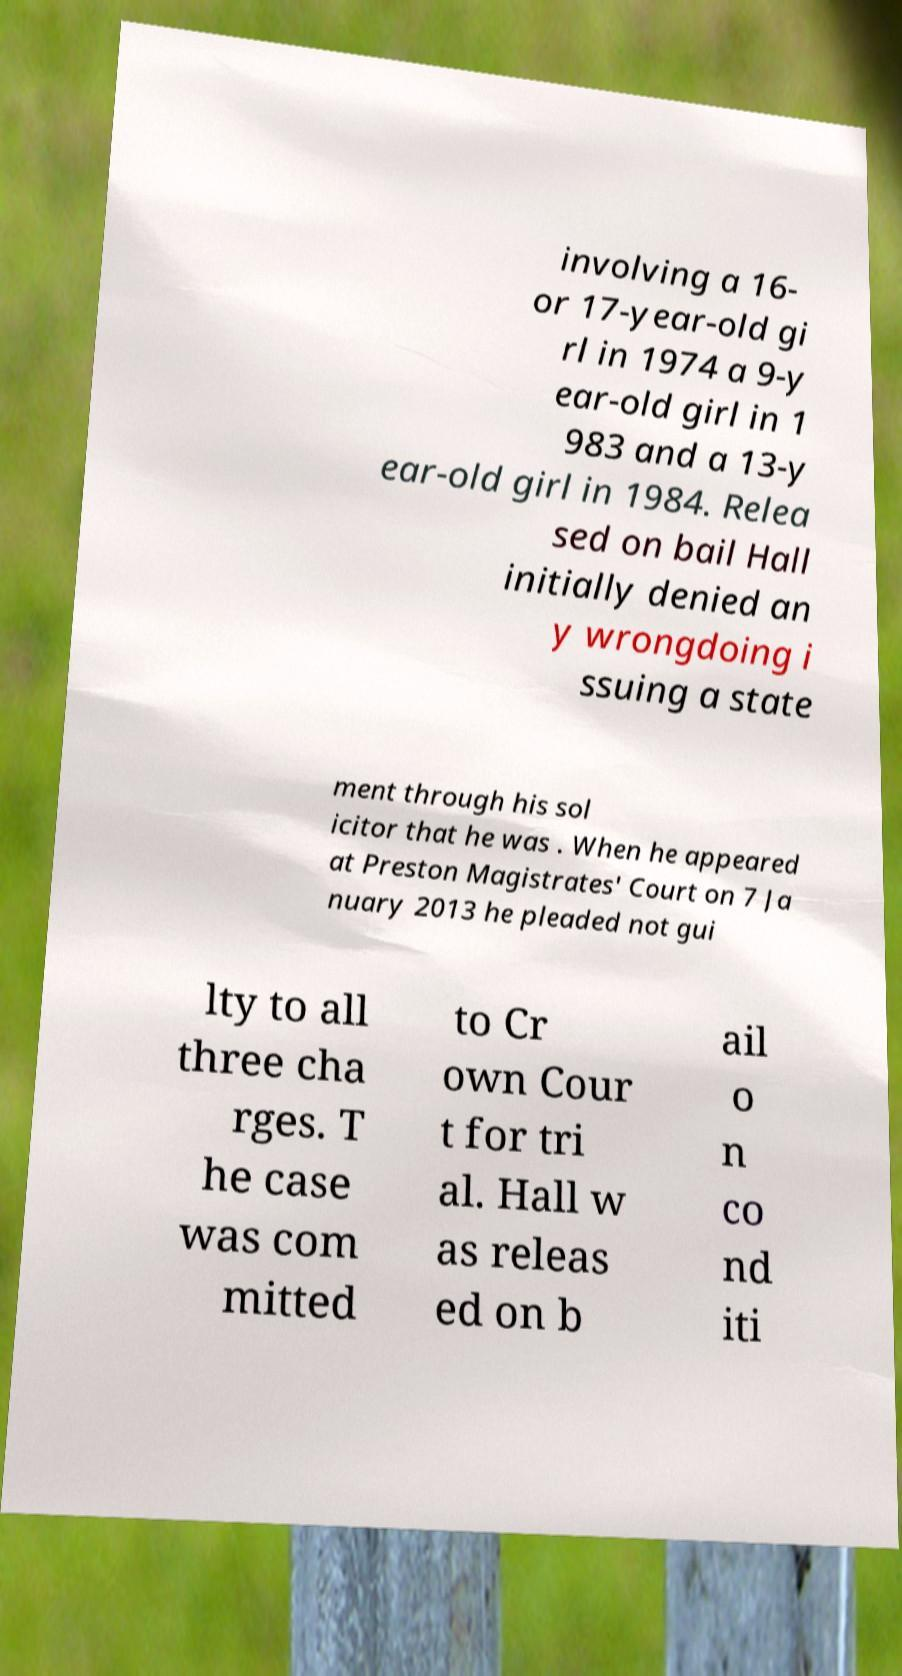Please read and relay the text visible in this image. What does it say? involving a 16- or 17-year-old gi rl in 1974 a 9-y ear-old girl in 1 983 and a 13-y ear-old girl in 1984. Relea sed on bail Hall initially denied an y wrongdoing i ssuing a state ment through his sol icitor that he was . When he appeared at Preston Magistrates' Court on 7 Ja nuary 2013 he pleaded not gui lty to all three cha rges. T he case was com mitted to Cr own Cour t for tri al. Hall w as releas ed on b ail o n co nd iti 